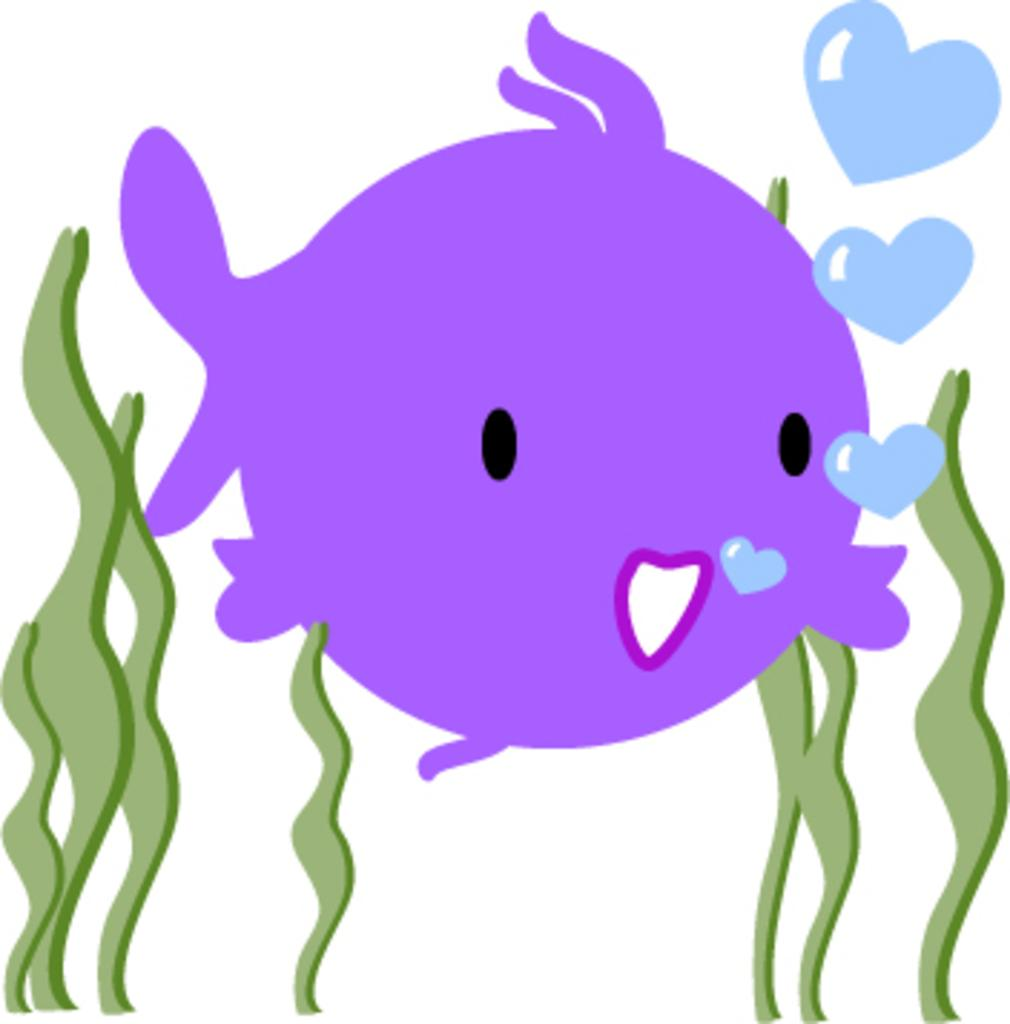What type of animal is depicted in the image? There is a cartoon fish in the image. What color is the cartoon fish? The cartoon fish is purple. What type of vegetation can be seen on both sides of the image? There is grass on both sides of the image. What color is the background of the image? The background of the image is white. What is the rate of the police car passing by in the image? There is no police car present in the image, so it is not possible to determine the rate at which it might be passing by. 